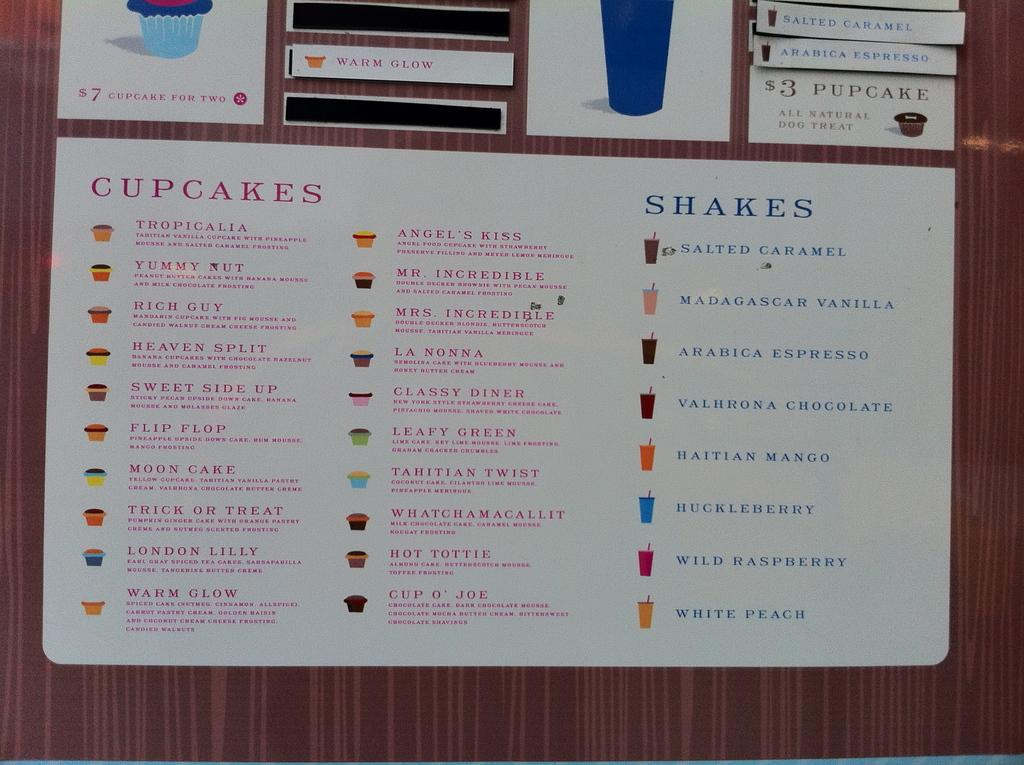What is the main object in the image? There is a notice board in the image. What is attached to the notice board? There are papers on the notice board. What information is present on the papers? The papers contain text and have pictures of cupcakes and glasses. How does the notice board affect the mind of the person viewing the image? The notice board does not affect the mind of the person viewing the image; it is an inanimate object. 